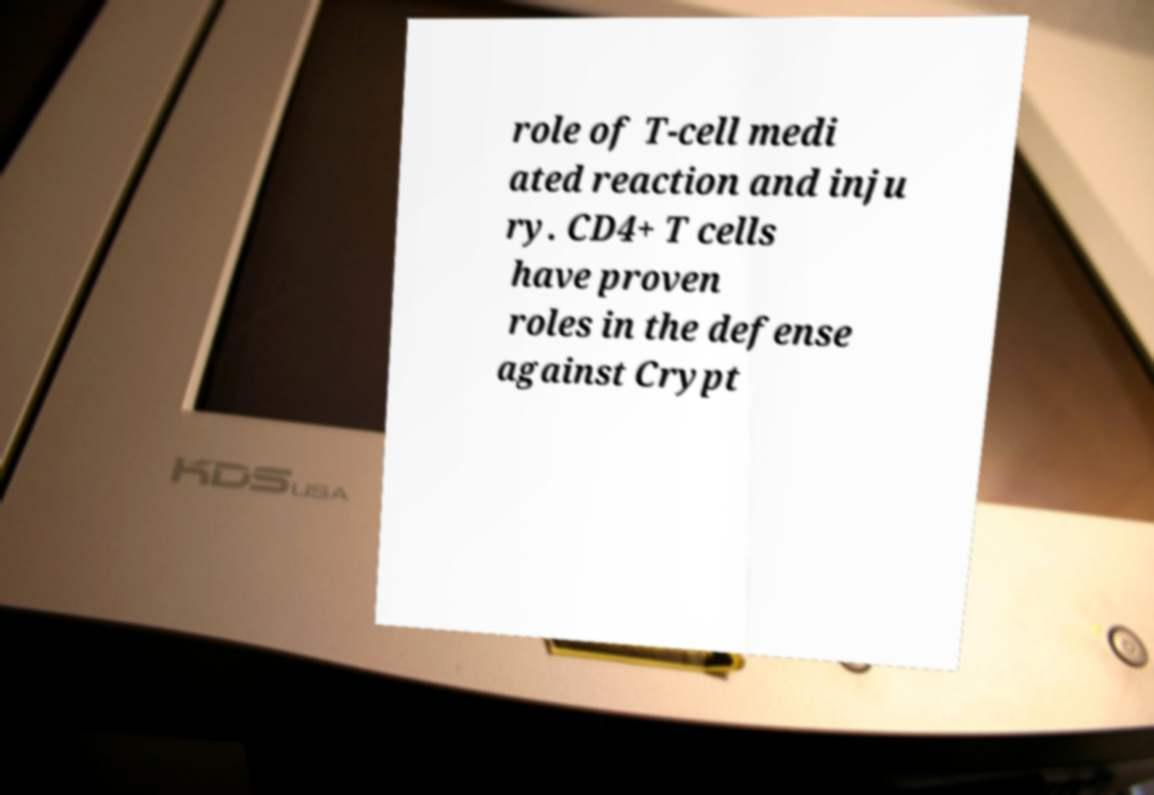Please read and relay the text visible in this image. What does it say? role of T-cell medi ated reaction and inju ry. CD4+ T cells have proven roles in the defense against Crypt 